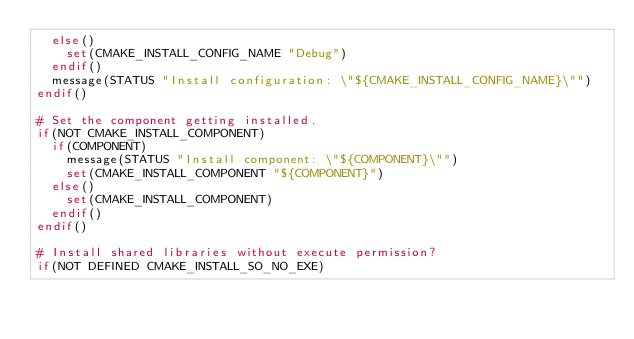Convert code to text. <code><loc_0><loc_0><loc_500><loc_500><_CMake_>  else()
    set(CMAKE_INSTALL_CONFIG_NAME "Debug")
  endif()
  message(STATUS "Install configuration: \"${CMAKE_INSTALL_CONFIG_NAME}\"")
endif()

# Set the component getting installed.
if(NOT CMAKE_INSTALL_COMPONENT)
  if(COMPONENT)
    message(STATUS "Install component: \"${COMPONENT}\"")
    set(CMAKE_INSTALL_COMPONENT "${COMPONENT}")
  else()
    set(CMAKE_INSTALL_COMPONENT)
  endif()
endif()

# Install shared libraries without execute permission?
if(NOT DEFINED CMAKE_INSTALL_SO_NO_EXE)</code> 